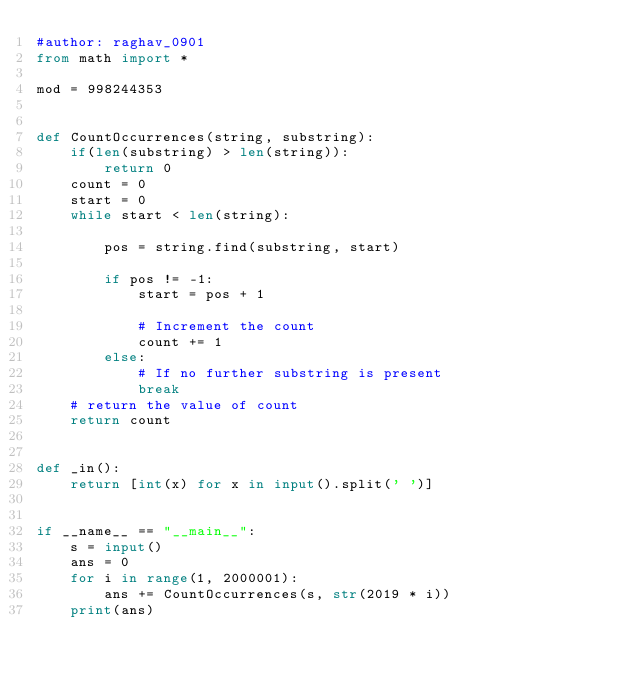<code> <loc_0><loc_0><loc_500><loc_500><_Python_>#author: raghav_0901
from math import *

mod = 998244353


def CountOccurrences(string, substring):
    if(len(substring) > len(string)):
        return 0
    count = 0
    start = 0
    while start < len(string):

        pos = string.find(substring, start)

        if pos != -1:
            start = pos + 1

            # Increment the count
            count += 1
        else:
            # If no further substring is present
            break
    # return the value of count
    return count


def _in():
    return [int(x) for x in input().split(' ')]


if __name__ == "__main__":
    s = input()
    ans = 0
    for i in range(1, 2000001):
        ans += CountOccurrences(s, str(2019 * i))
    print(ans)
</code> 